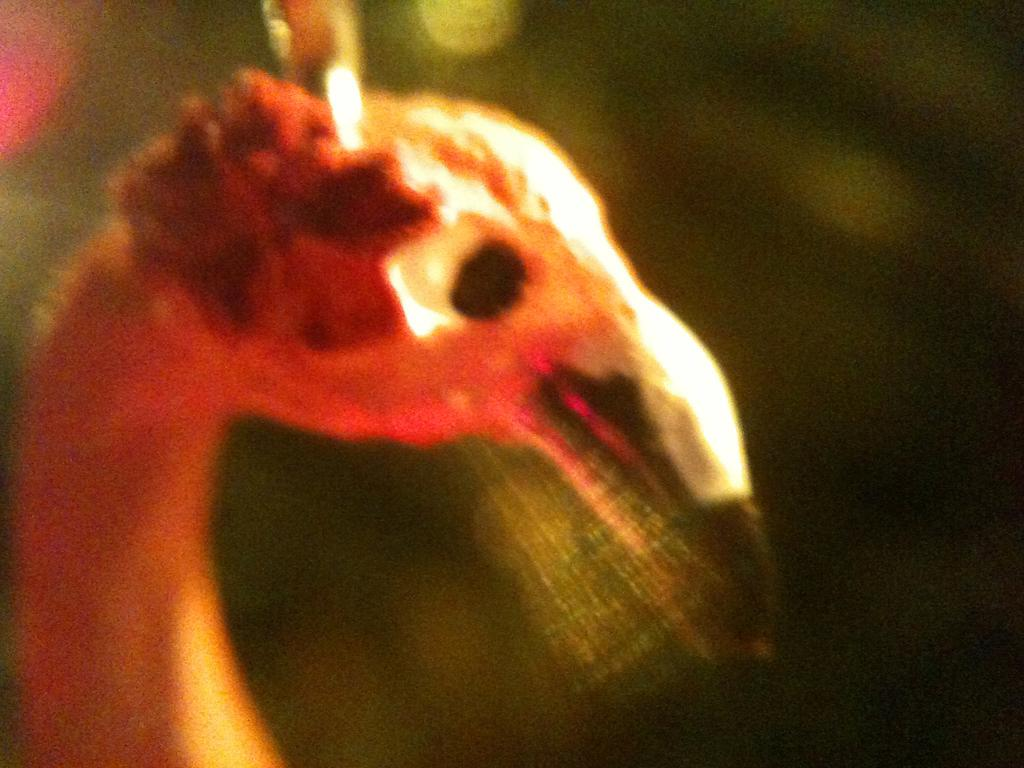What type of animals can be seen in the image? Birds can be seen in the image. What colors are present on the faces of the birds? The faces of the birds have red and white colors. What type of horn can be seen on the birds in the image? There is no horn present on the birds in the image. What type of connection can be seen between the birds in the image? There is no connection between the birds in the image; they are separate entities. What type of chess piece do the birds resemble in the image? The birds do not resemble any chess pieces in the image. 